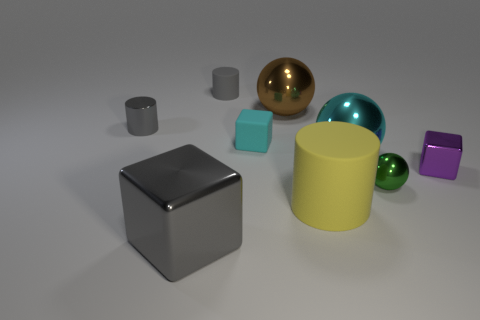What number of shiny objects are the same color as the tiny matte cylinder?
Provide a succinct answer. 2. Does the green ball have the same material as the small cyan thing?
Your response must be concise. No. How many objects are big cyan matte spheres or yellow rubber cylinders?
Make the answer very short. 1. How many small yellow objects are made of the same material as the tiny purple thing?
Offer a terse response. 0. What is the size of the gray shiny object that is the same shape as the large yellow object?
Your answer should be compact. Small. Are there any cubes to the left of the cyan block?
Offer a very short reply. Yes. What is the cyan cube made of?
Your answer should be very brief. Rubber. Is the color of the ball behind the big cyan thing the same as the big cylinder?
Provide a succinct answer. No. Are there any other things that have the same shape as the big brown object?
Your answer should be compact. Yes. There is another big object that is the same shape as the cyan shiny object; what is its color?
Offer a very short reply. Brown. 